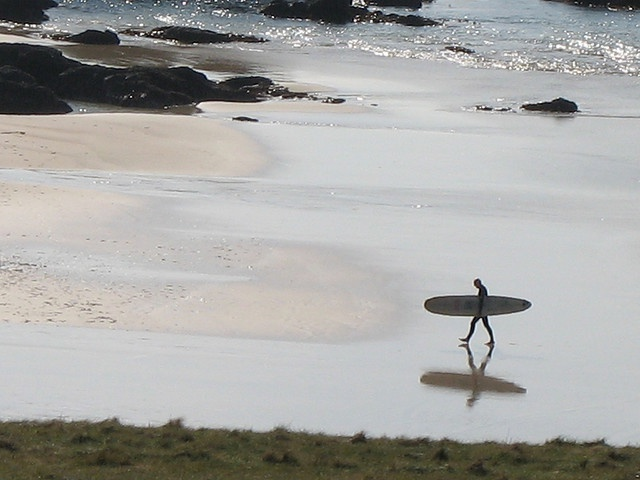Describe the objects in this image and their specific colors. I can see surfboard in black, gray, and purple tones and people in black, gray, and darkgray tones in this image. 